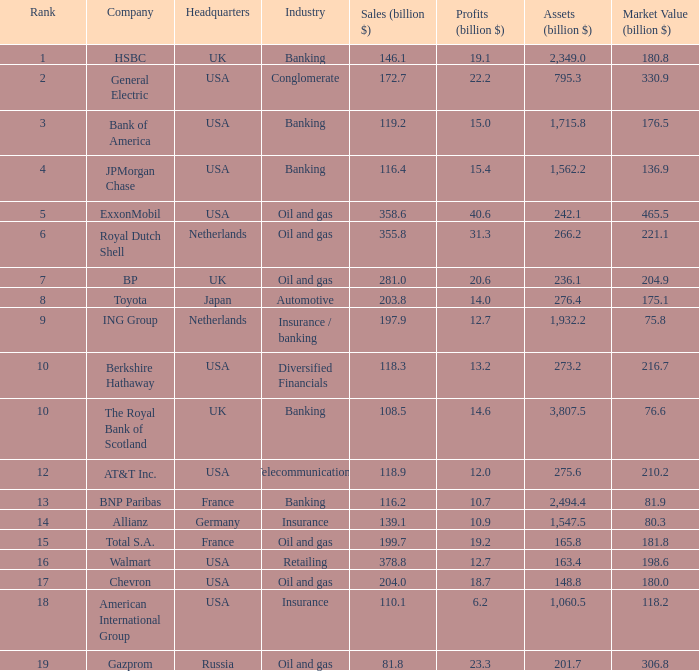What is the market value of a company in billions that has 172.7 billion in sales?  330.9. 